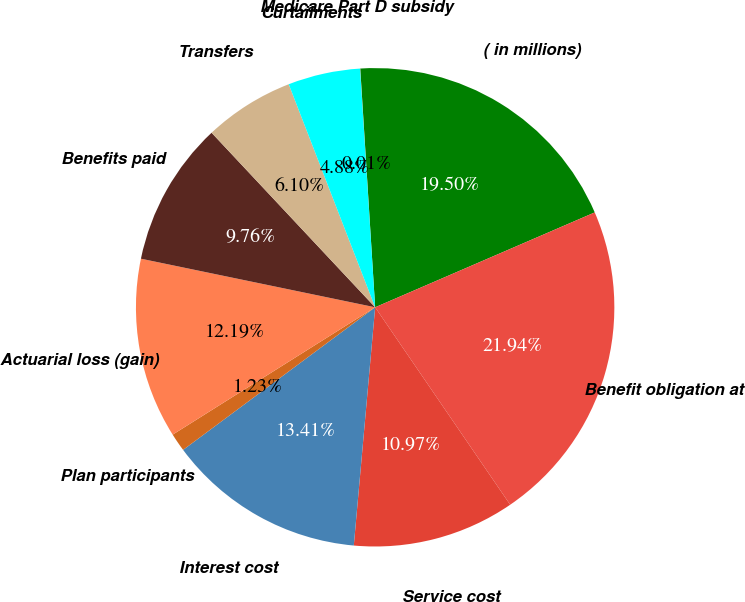Convert chart to OTSL. <chart><loc_0><loc_0><loc_500><loc_500><pie_chart><fcel>( in millions)<fcel>Benefit obligation at<fcel>Service cost<fcel>Interest cost<fcel>Plan participants<fcel>Actuarial loss (gain)<fcel>Benefits paid<fcel>Transfers<fcel>Curtailments<fcel>Medicare Part D subsidy<nl><fcel>19.5%<fcel>21.94%<fcel>10.97%<fcel>13.41%<fcel>1.23%<fcel>12.19%<fcel>9.76%<fcel>6.1%<fcel>4.88%<fcel>0.01%<nl></chart> 